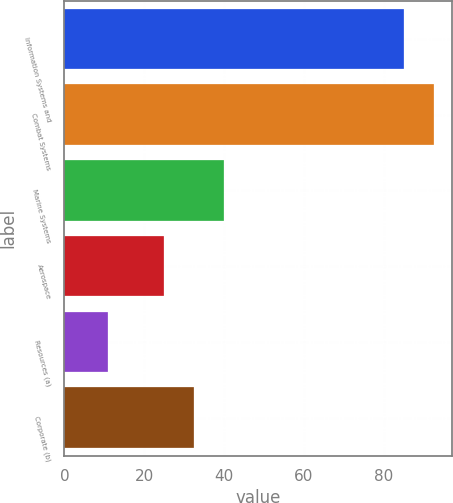Convert chart. <chart><loc_0><loc_0><loc_500><loc_500><bar_chart><fcel>Information Systems and<fcel>Combat Systems<fcel>Marine Systems<fcel>Aerospace<fcel>Resources (a)<fcel>Corporate (b)<nl><fcel>85<fcel>92.5<fcel>40<fcel>25<fcel>11<fcel>32.5<nl></chart> 